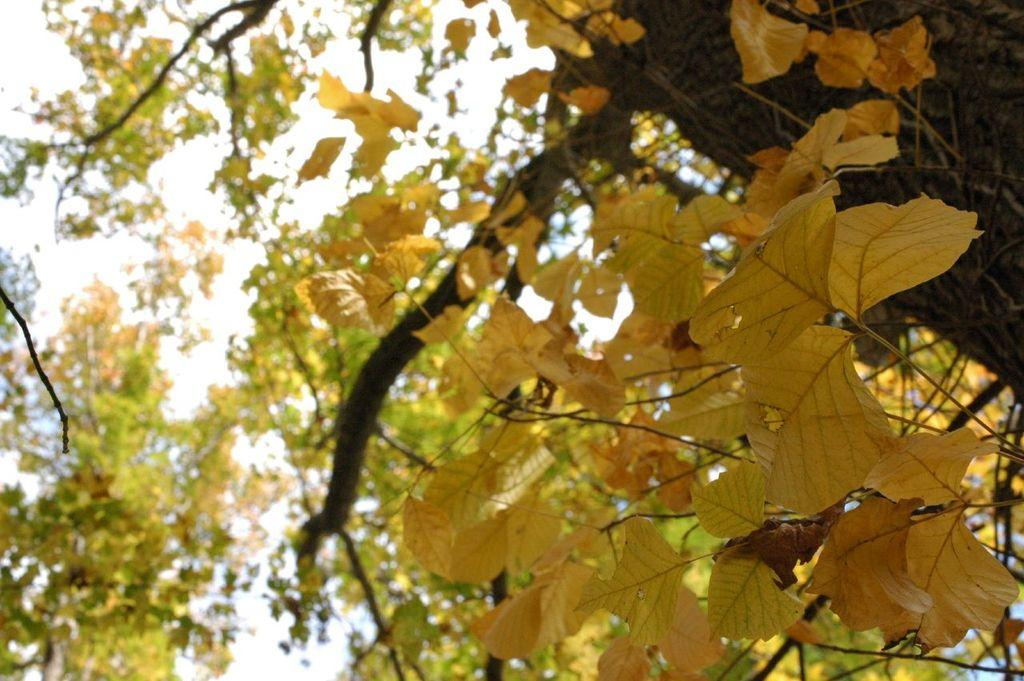What color are the leaves in the image? The leaves in the image are yellow. What is the background of the image? The background of the image is the sky. What color is the sky in the image? The sky in the image is white. Can you see a fan in the image? There is no fan present in the image. Is there a bear visible in the image? There is no bear present in the image. 